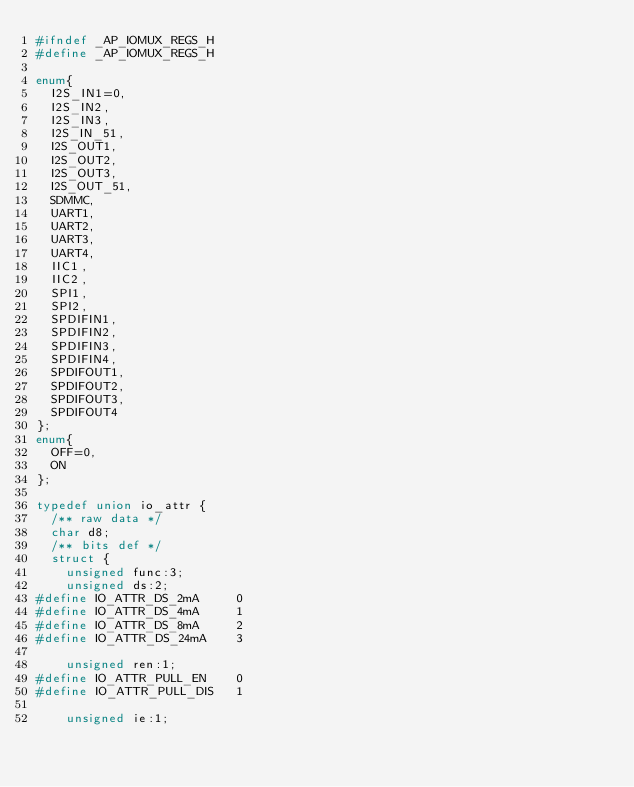<code> <loc_0><loc_0><loc_500><loc_500><_C_>#ifndef _AP_IOMUX_REGS_H
#define _AP_IOMUX_REGS_H

enum{
	I2S_IN1=0,
	I2S_IN2,
	I2S_IN3,
	I2S_IN_51,
	I2S_OUT1,
	I2S_OUT2,
	I2S_OUT3,
	I2S_OUT_51,
	SDMMC,
	UART1,
	UART2,
	UART3,
	UART4,
	IIC1,
	IIC2,
	SPI1,
	SPI2,
	SPDIFIN1,
	SPDIFIN2,
	SPDIFIN3,
	SPDIFIN4,
	SPDIFOUT1,
	SPDIFOUT2,
	SPDIFOUT3,
	SPDIFOUT4
};
enum{
	OFF=0,
	ON
};

typedef union io_attr {
	/** raw data */
	char d8;
	/** bits def */
	struct {
		unsigned func:3;
		unsigned ds:2;
#define IO_ATTR_DS_2mA     0
#define IO_ATTR_DS_4mA     1
#define IO_ATTR_DS_8mA     2
#define IO_ATTR_DS_24mA    3

		unsigned ren:1;
#define IO_ATTR_PULL_EN    0
#define IO_ATTR_PULL_DIS   1

		unsigned ie:1;</code> 